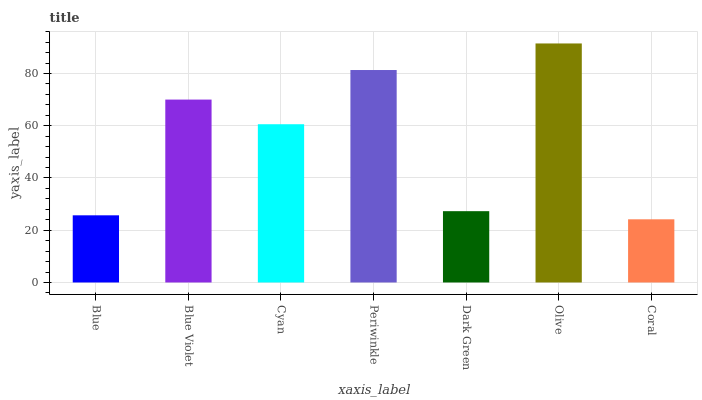Is Blue Violet the minimum?
Answer yes or no. No. Is Blue Violet the maximum?
Answer yes or no. No. Is Blue Violet greater than Blue?
Answer yes or no. Yes. Is Blue less than Blue Violet?
Answer yes or no. Yes. Is Blue greater than Blue Violet?
Answer yes or no. No. Is Blue Violet less than Blue?
Answer yes or no. No. Is Cyan the high median?
Answer yes or no. Yes. Is Cyan the low median?
Answer yes or no. Yes. Is Coral the high median?
Answer yes or no. No. Is Periwinkle the low median?
Answer yes or no. No. 